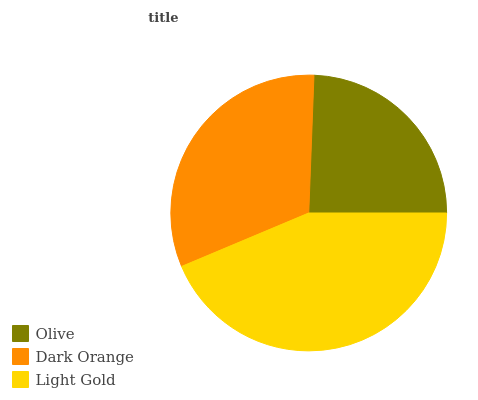Is Olive the minimum?
Answer yes or no. Yes. Is Light Gold the maximum?
Answer yes or no. Yes. Is Dark Orange the minimum?
Answer yes or no. No. Is Dark Orange the maximum?
Answer yes or no. No. Is Dark Orange greater than Olive?
Answer yes or no. Yes. Is Olive less than Dark Orange?
Answer yes or no. Yes. Is Olive greater than Dark Orange?
Answer yes or no. No. Is Dark Orange less than Olive?
Answer yes or no. No. Is Dark Orange the high median?
Answer yes or no. Yes. Is Dark Orange the low median?
Answer yes or no. Yes. Is Light Gold the high median?
Answer yes or no. No. Is Light Gold the low median?
Answer yes or no. No. 